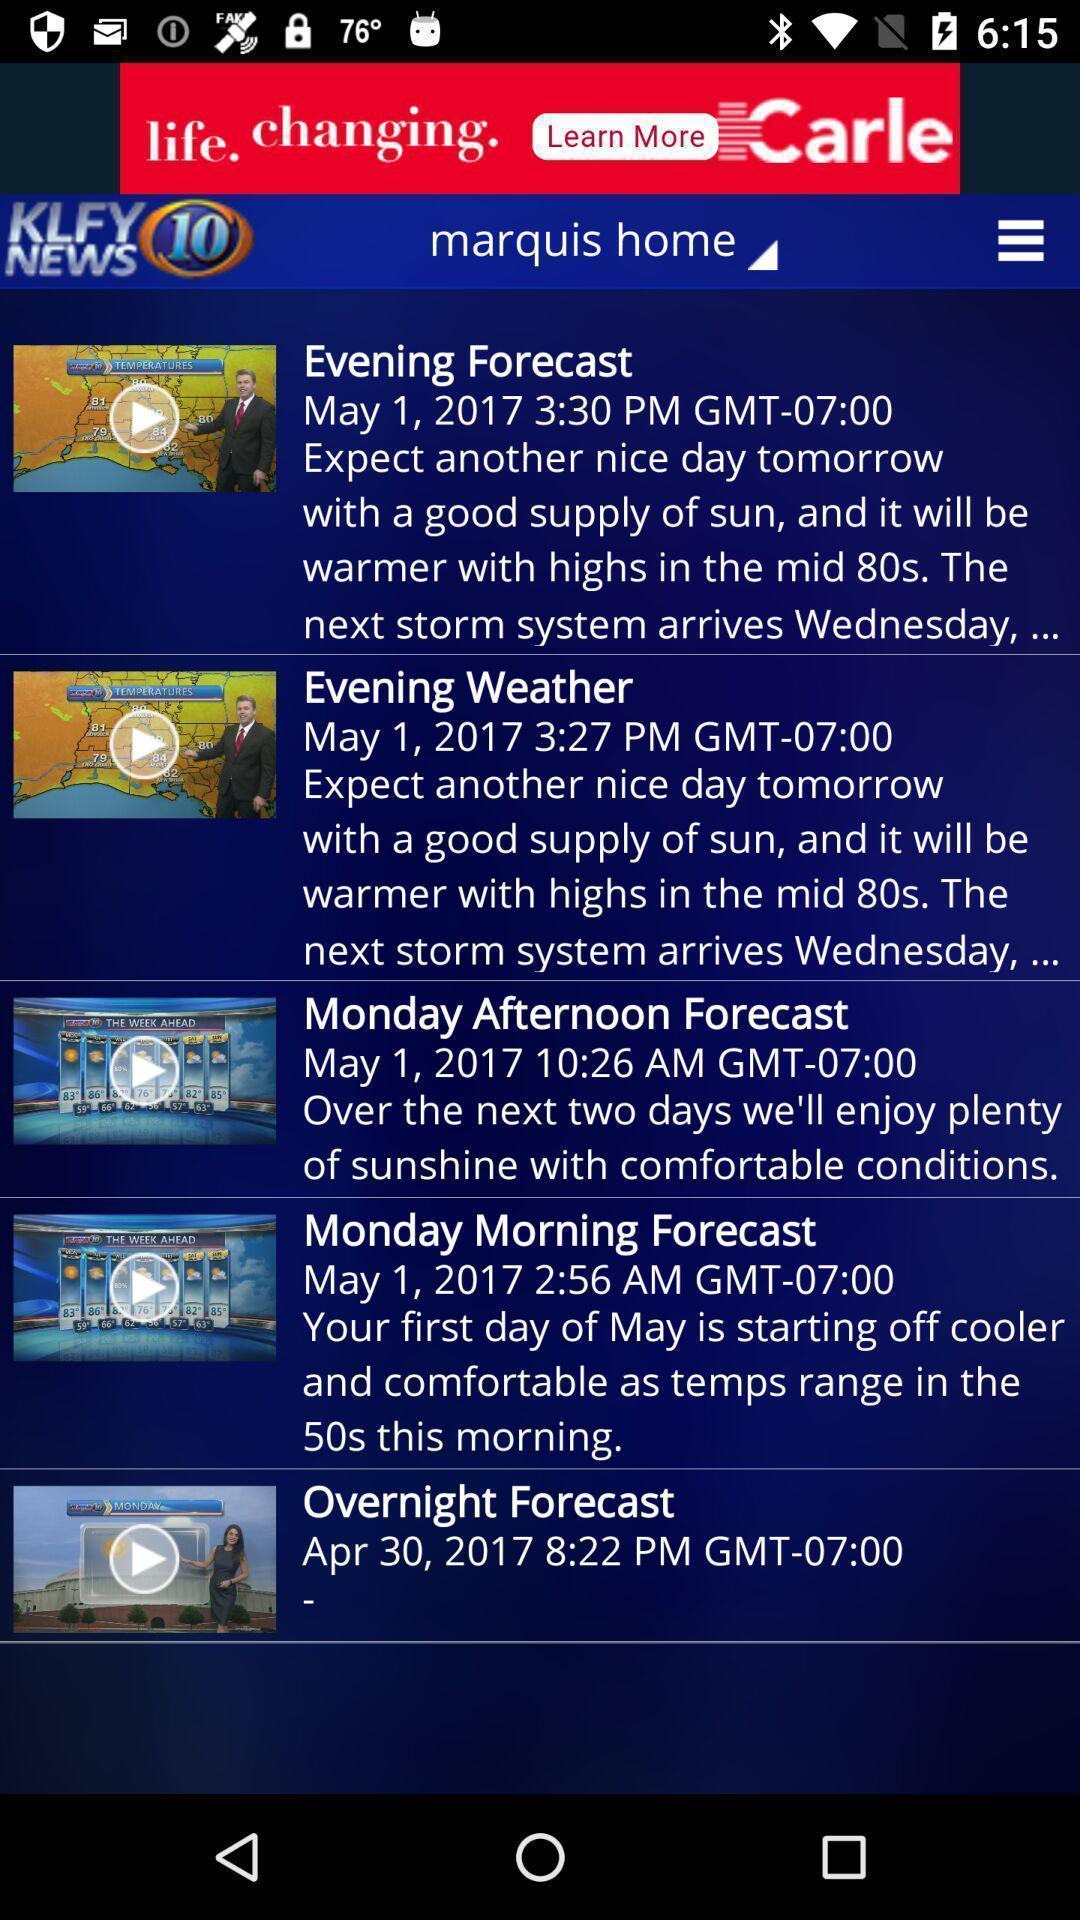Provide a textual representation of this image. Page showing list of weather reports in weather forecasting app. 